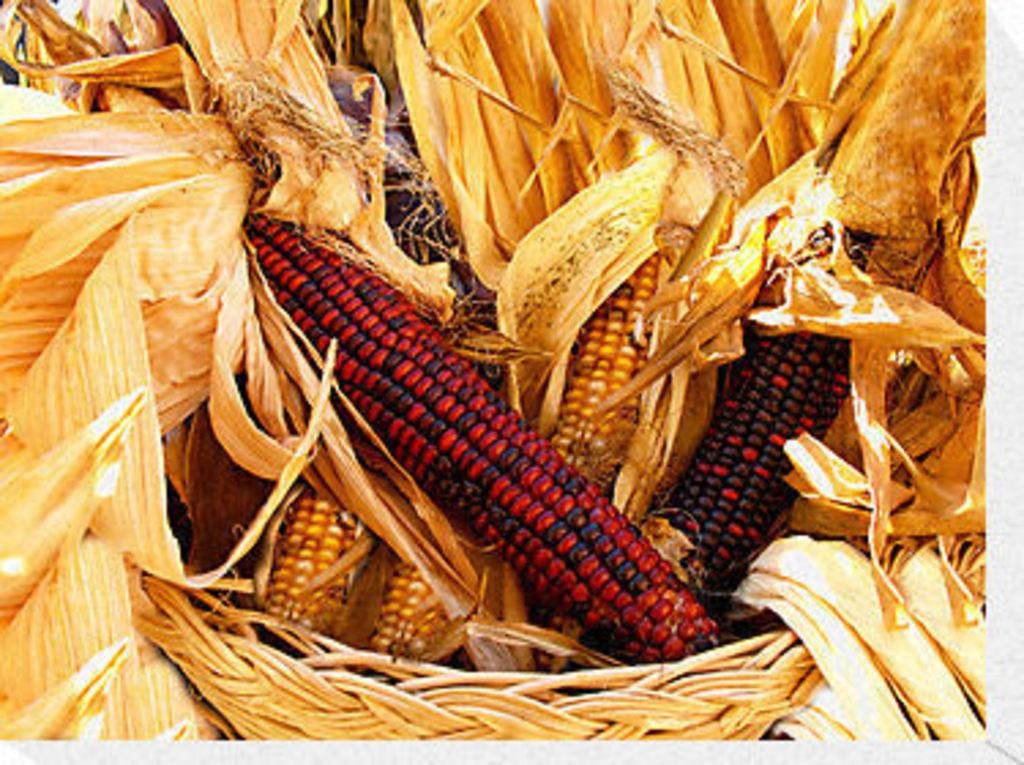What type of food is present in the image? There is corn in the image. What type of friction can be observed between the corn kernels in the image? There is no friction observable between the corn kernels in the image, as friction is a physical property and not a visible characteristic. 